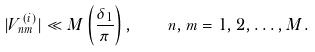Convert formula to latex. <formula><loc_0><loc_0><loc_500><loc_500>| V _ { n m } ^ { ( i ) } | \ll M \left ( \frac { \delta _ { 1 } } { \pi } \right ) , \quad n , m = 1 , 2 , \dots , M .</formula> 